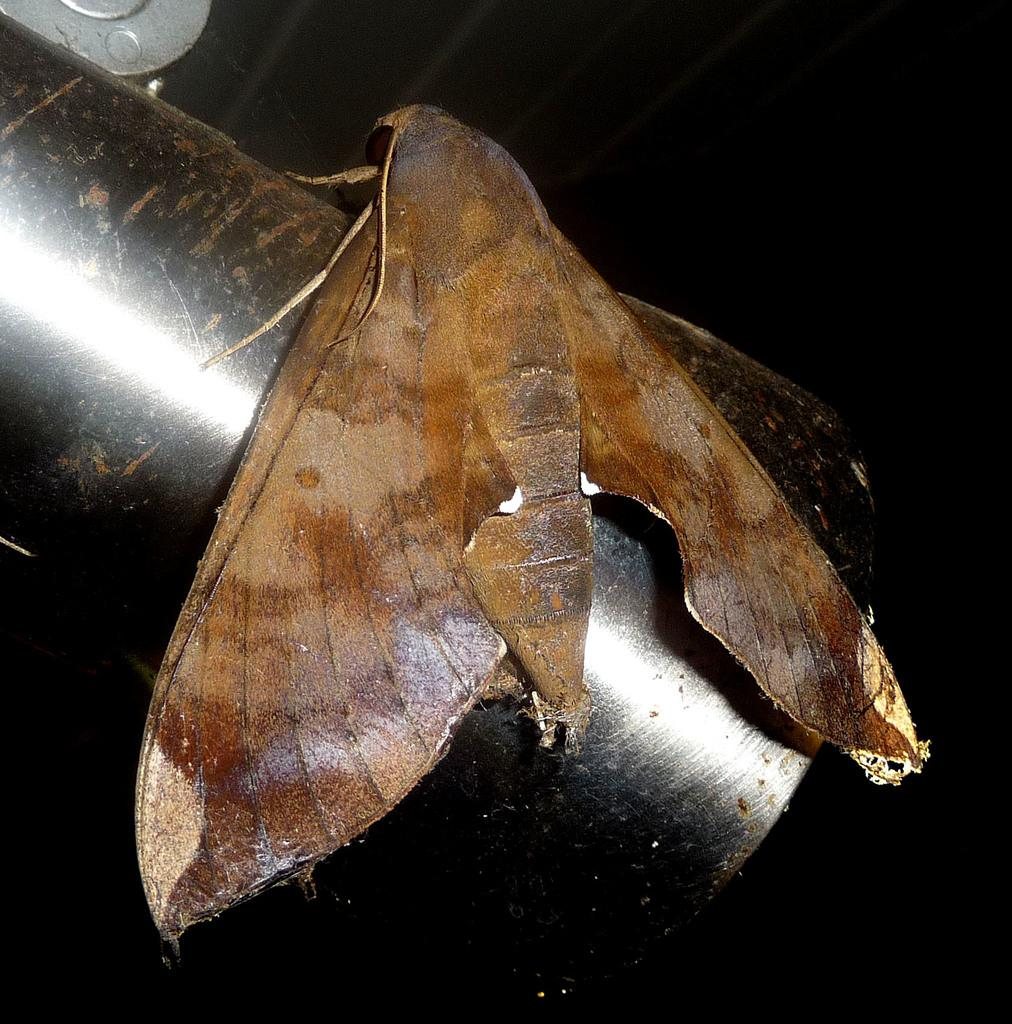What can be seen in the image? There is an object in the image. What is the color of the object? The object is brown in color. Where is the object located? The object is on a pipe. What is the color of the pipe? The pipe is black in color. What flavor does the object on the pipe have? The facts provided do not mention any flavor associated with the object, so it cannot be determined from the image. 